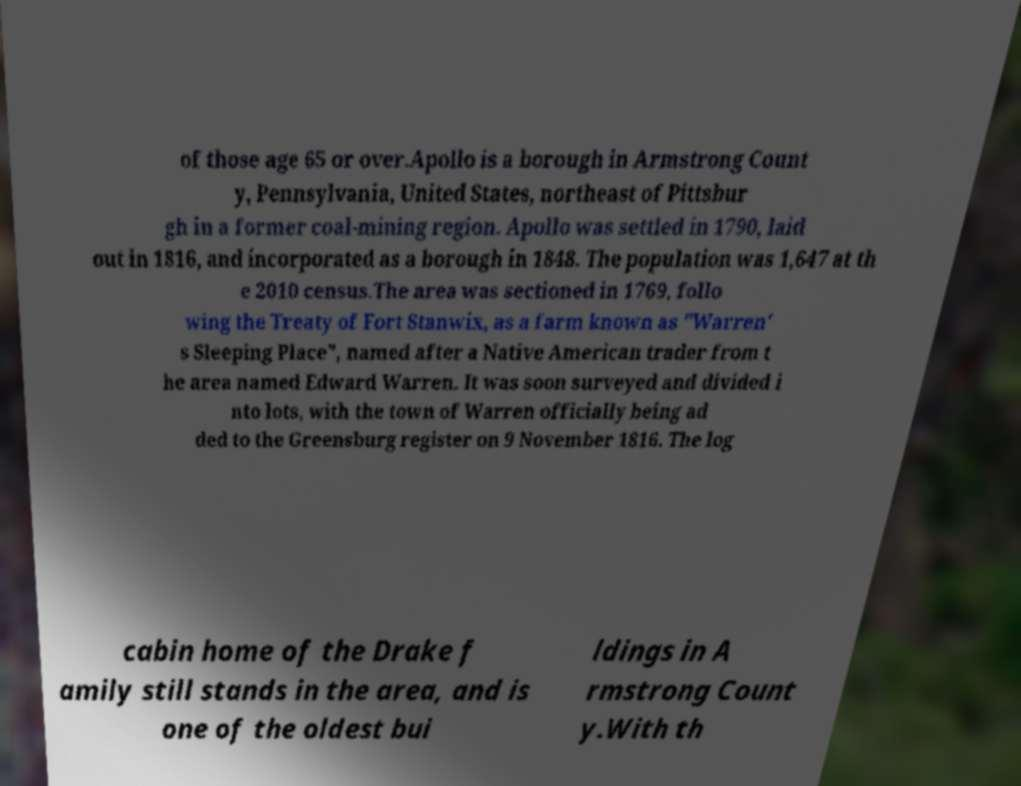For documentation purposes, I need the text within this image transcribed. Could you provide that? of those age 65 or over.Apollo is a borough in Armstrong Count y, Pennsylvania, United States, northeast of Pittsbur gh in a former coal-mining region. Apollo was settled in 1790, laid out in 1816, and incorporated as a borough in 1848. The population was 1,647 at th e 2010 census.The area was sectioned in 1769, follo wing the Treaty of Fort Stanwix, as a farm known as "Warren' s Sleeping Place", named after a Native American trader from t he area named Edward Warren. It was soon surveyed and divided i nto lots, with the town of Warren officially being ad ded to the Greensburg register on 9 November 1816. The log cabin home of the Drake f amily still stands in the area, and is one of the oldest bui ldings in A rmstrong Count y.With th 